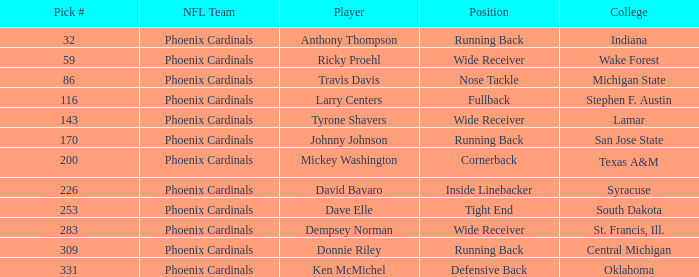What is the pick# from South Dakota college? 253.0. 